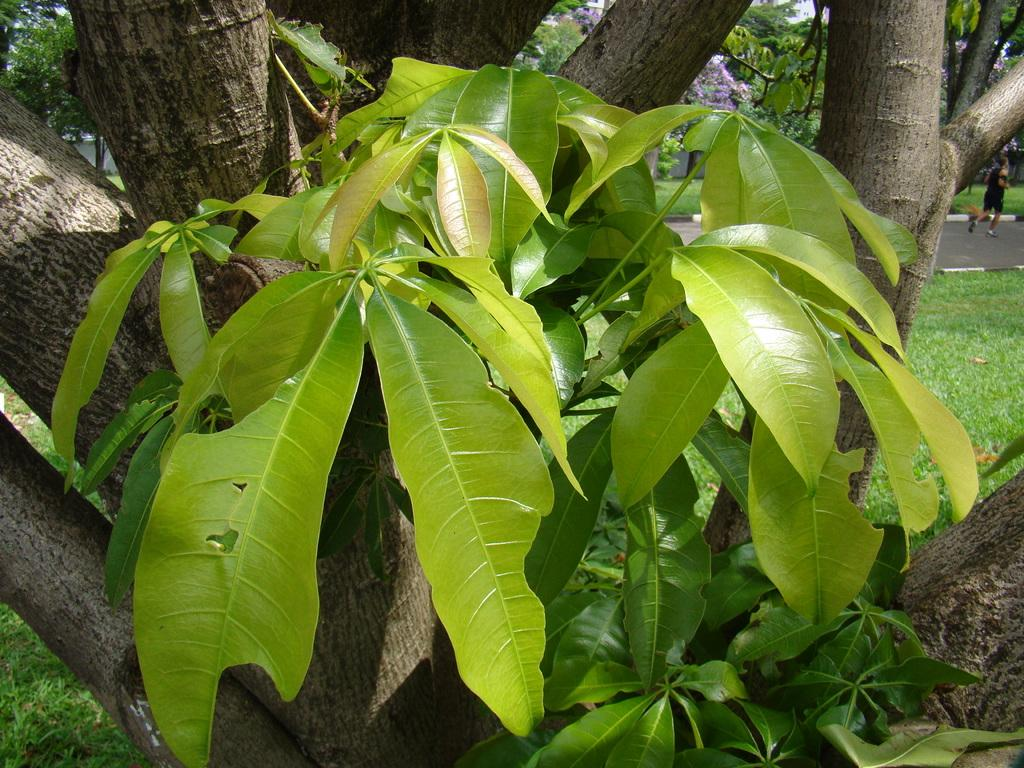What type of plant can be seen in the image? There is a tree in the image. Can you describe the background of the image? There is a person and grass in the background of the image. What other plants are visible in the background? There are trees in the background of the image. What type of stitch is being used to repair the person's clothing in the image? There is no indication in the image that the person's clothing is being repaired or that any stitching is taking place. 